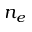Convert formula to latex. <formula><loc_0><loc_0><loc_500><loc_500>n _ { e }</formula> 